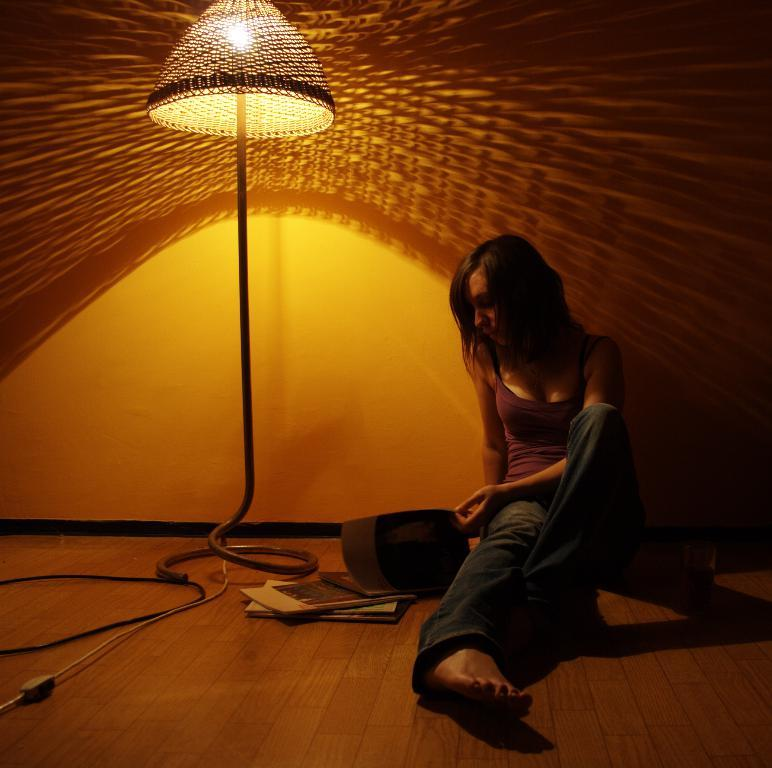What is the woman in the image doing? The woman is sitting on the floor in the image. Can you describe the woman's surroundings? The woman is near a light, and there are wires and books on the floor in the image. What can be seen in the background of the image? There is a wall in the background of the image. How does the woman show her loss in the image? There is no indication of loss in the image, and the woman is not displaying any emotions or actions related to loss. 